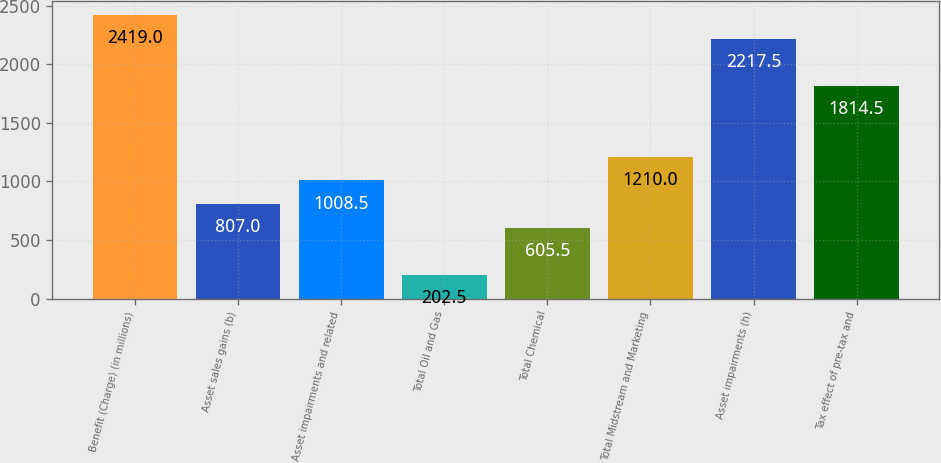Convert chart to OTSL. <chart><loc_0><loc_0><loc_500><loc_500><bar_chart><fcel>Benefit (Charge) (in millions)<fcel>Asset sales gains (b)<fcel>Asset impairments and related<fcel>Total Oil and Gas<fcel>Total Chemical<fcel>Total Midstream and Marketing<fcel>Asset impairments (h)<fcel>Tax effect of pre-tax and<nl><fcel>2419<fcel>807<fcel>1008.5<fcel>202.5<fcel>605.5<fcel>1210<fcel>2217.5<fcel>1814.5<nl></chart> 